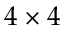<formula> <loc_0><loc_0><loc_500><loc_500>4 \times 4</formula> 